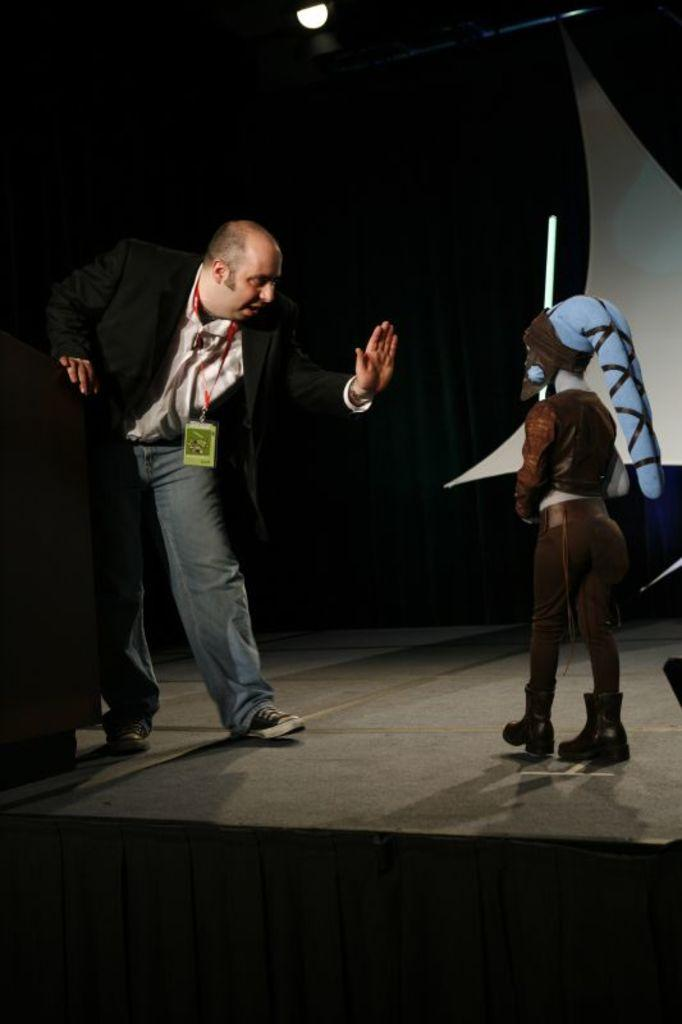How many people are on the stage in the image? There are two persons on the stage in the image. What can be seen in the background behind the stage? There is a curtain and a light in the background. Can you tell if the image was taken during the day or night? The image may have been taken during nighttime. What type of floor material can be seen in the image? There is no information about the floor material in the image. 